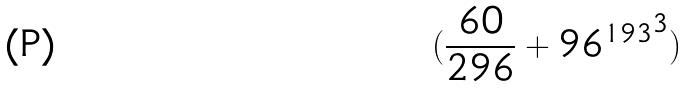<formula> <loc_0><loc_0><loc_500><loc_500>( \frac { 6 0 } { 2 9 6 } + { 9 6 ^ { 1 9 3 } } ^ { 3 } )</formula> 